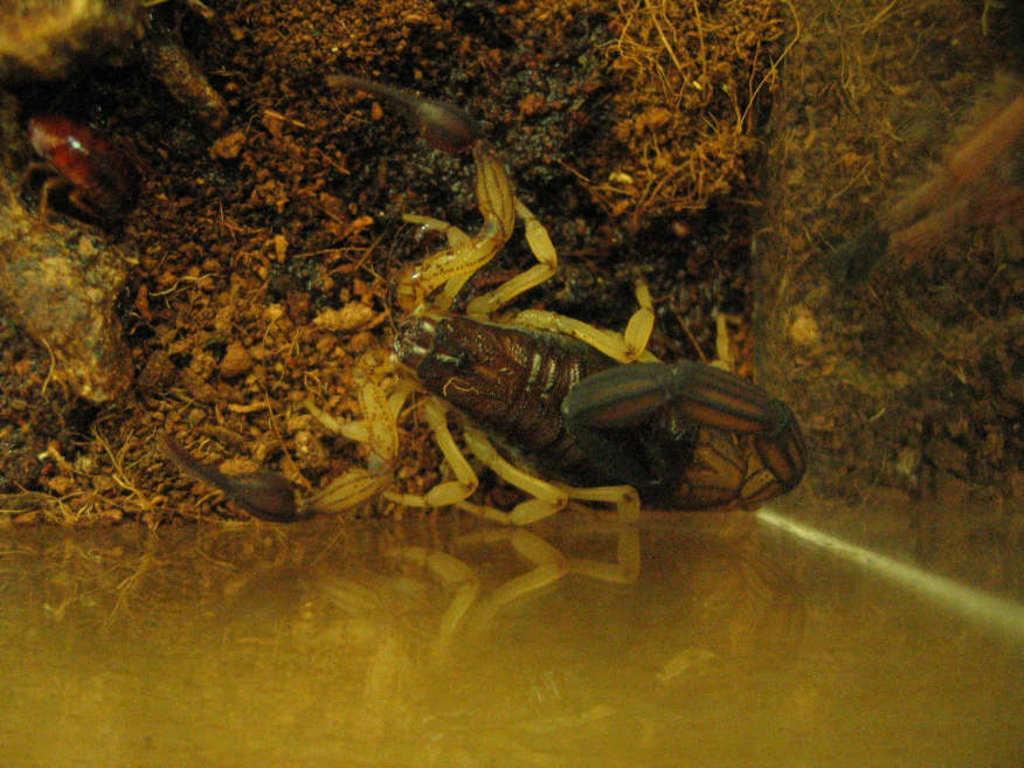Can you describe this image briefly? This picture contains an insect in brown and black color is in the soil. At the bottom of the picture, it is blurred. 